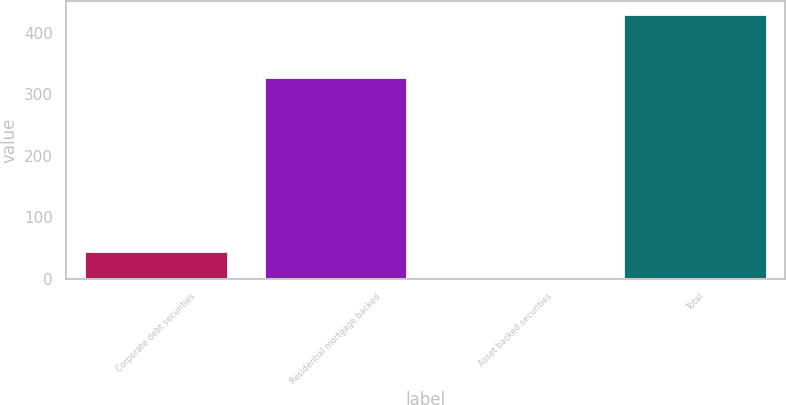Convert chart to OTSL. <chart><loc_0><loc_0><loc_500><loc_500><bar_chart><fcel>Corporate debt securities<fcel>Residential mortgage backed<fcel>Asset backed securities<fcel>Total<nl><fcel>45.7<fcel>328<fcel>3<fcel>430<nl></chart> 